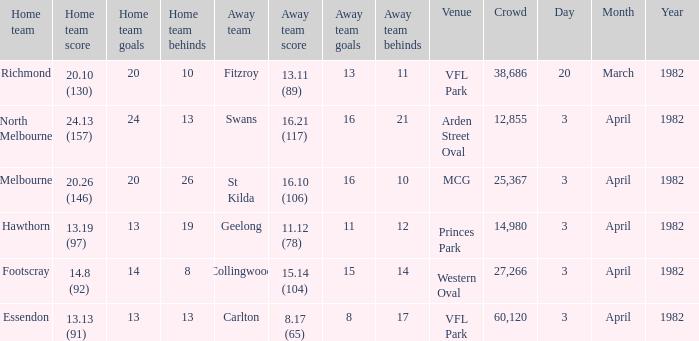What score did the home team of north melbourne get? 24.13 (157). 